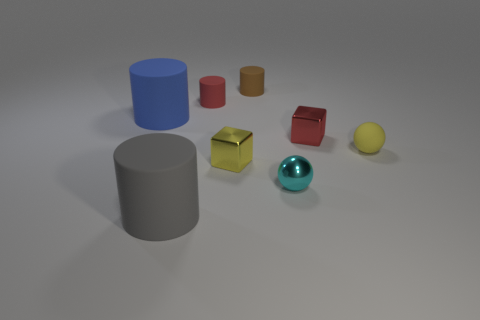Can you describe the shapes and colors of the objects in the foreground? In the foreground, there are two cylindrical objects, one gray and one blue, along with a shiny metallic sphere that appears teal in color. 